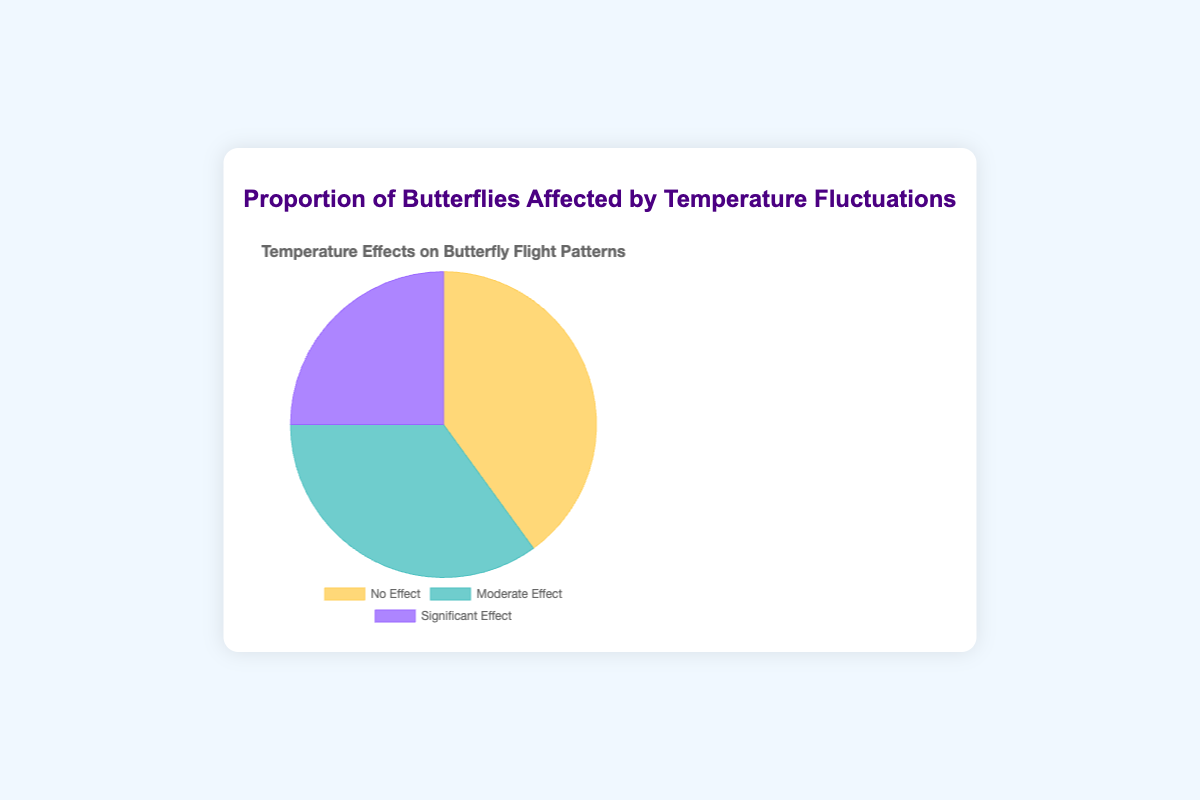What proportion of butterflies experienced no effect from temperature fluctuations? The 'No Effect' portion is shown in the chart legend as accounting for 40%.
Answer: 40% Between 'Moderate Effect' and 'Significant Effect', which had a greater impact on butterfly flight patterns? By comparing the proportions given in the chart, 'Moderate Effect' is 35% and 'Significant Effect' is 25%. Therefore, 'Moderate Effect' had a greater impact.
Answer: Moderate Effect What is the combined percentage of butterflies that experienced either no effect or a moderate effect due to temperature fluctuations? Summing the percentages of 'No Effect' (40%) and 'Moderate Effect' (35%), we get 40 + 35 = 75%.
Answer: 75% What portion of butterflies experienced significant effect relative to those that experienced moderate effect? To find the portion of butterflies that experienced a significant effect relative to those that experienced a moderate effect, divide the 'Significant Effect' percentage (25%) by the 'Moderate Effect' percentage (35%), yielding approximately 0.714.
Answer: 0.714 Which visual segment is represented by the color purple in the pie chart? From the chart legend, the 'Significant Effect' segment is represented by the color purple.
Answer: Significant Effect How much greater is the proportion of butterflies experiencing no effect compared to significant effect? By subtracting the 'Significant Effect' percentage (25%) from the 'No Effect' percentage (40%), we find the difference is 40 - 25 = 15%.
Answer: 15% If a new group of 100 butterflies were taken under the same temperature fluctuations, how many would you expect to show a moderate effect on their flight patterns? Given that 35% of the butterflies experienced a moderate effect, we calculate 35% of 100 to get the expected number by 100 * 0.35 = 35 butterflies.
Answer: 35 Which color corresponds to the highest proportion segment in the pie chart? By examining the chart, the 'No Effect' segment has the highest proportion and it is associated with the color yellow.
Answer: Yellow 